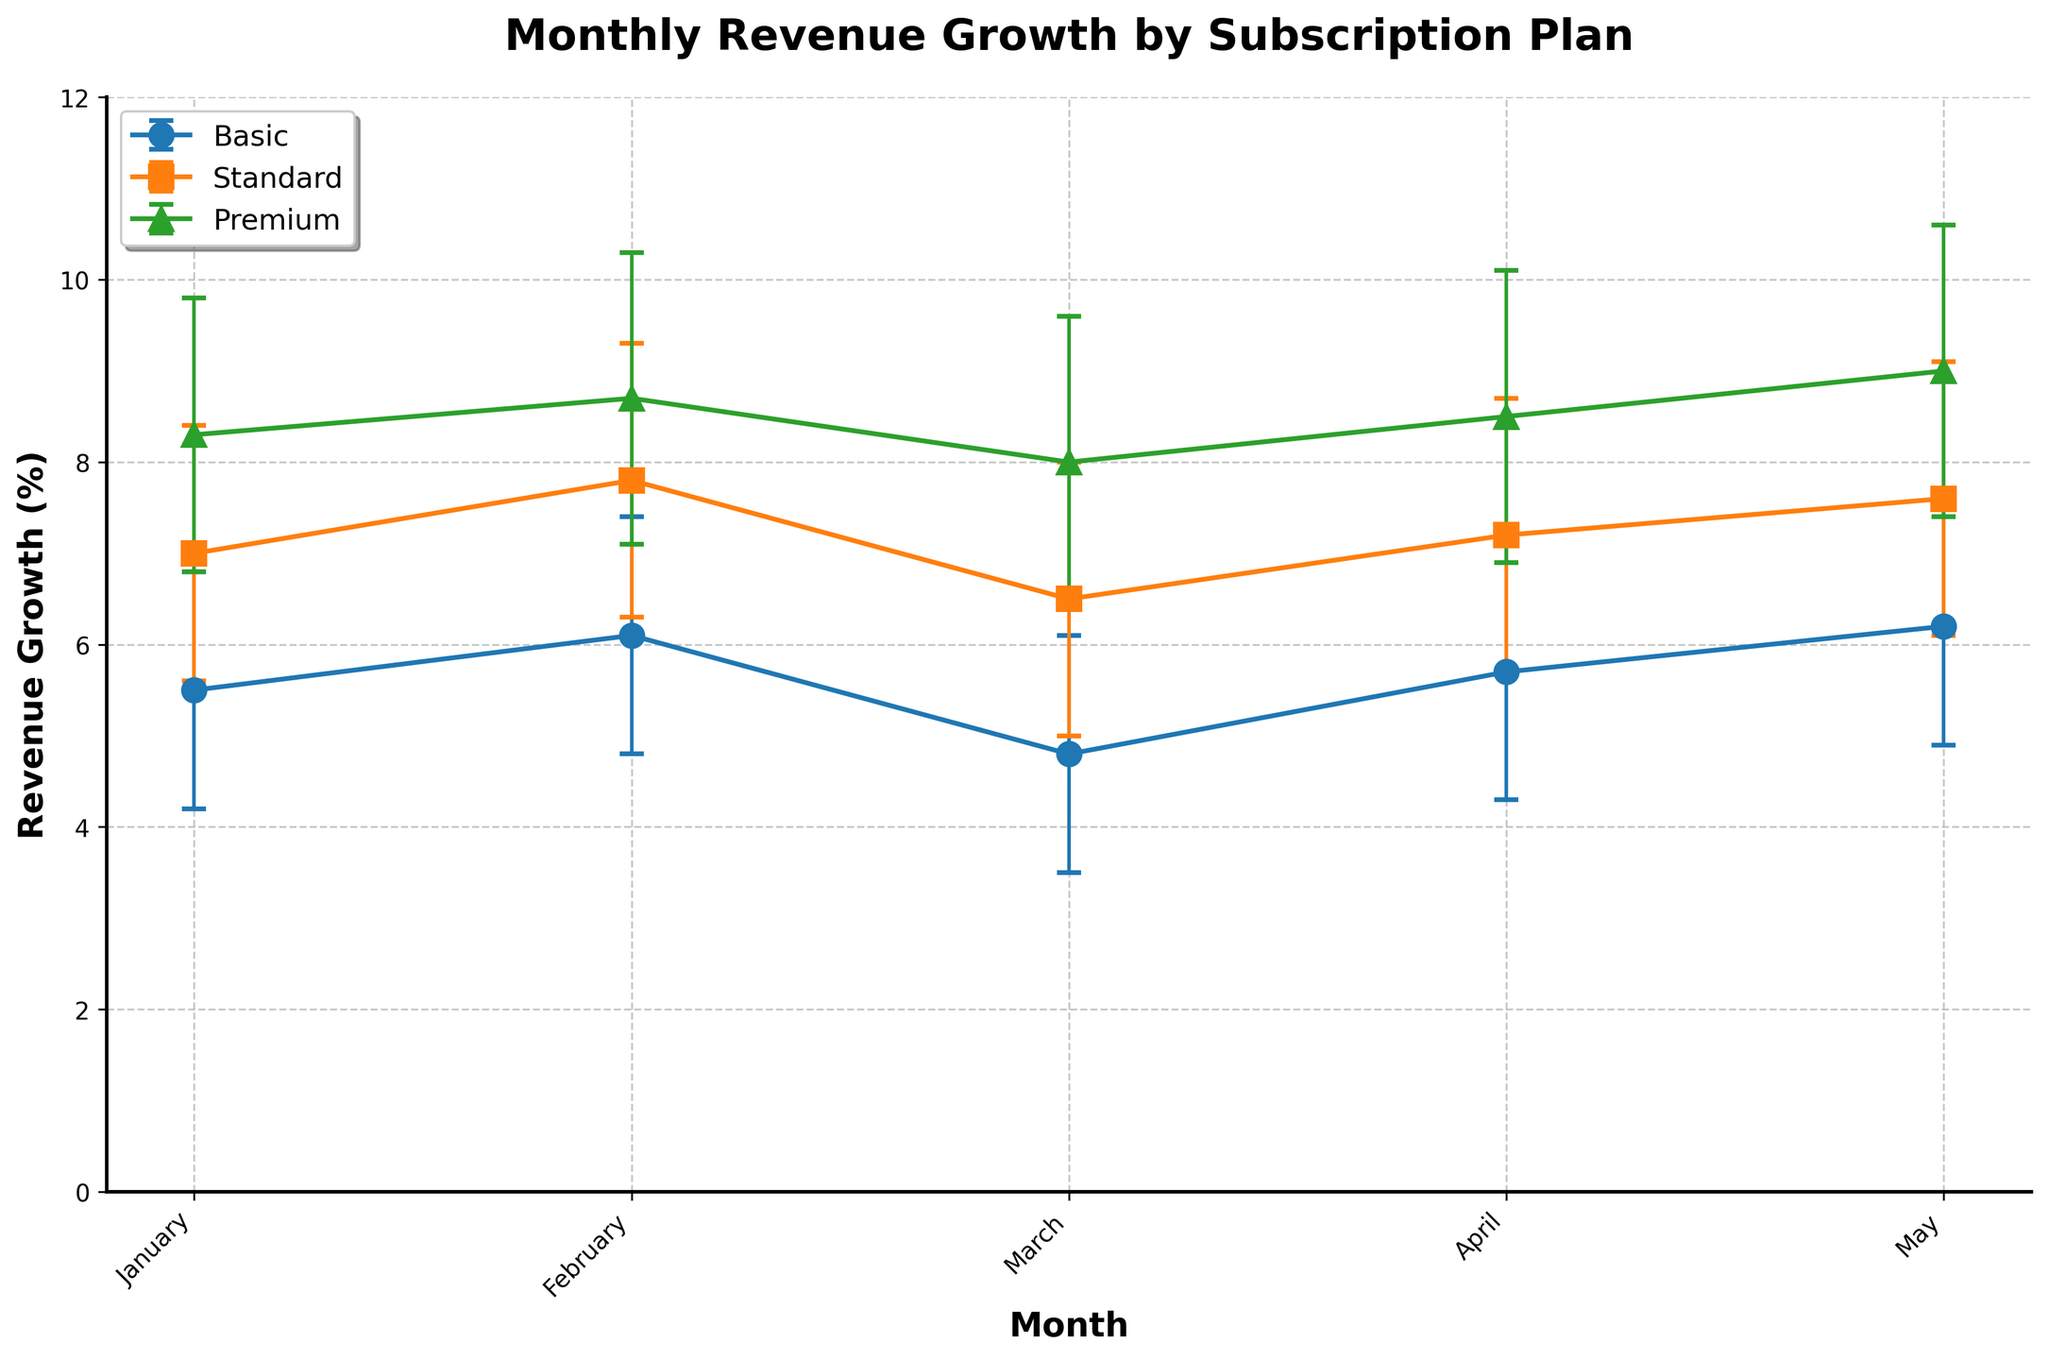What's the title of the figure? The title of the figure is located at the top center and it states the main focus of the visual representation.
Answer: Monthly Revenue Growth by Subscription Plan Which subscription plan shows the highest revenue growth in April? To find this, locate April on the x-axis and compare the revenue growth of all subscription plans. The plan with the highest value will be the highest on the y-axis for that month.
Answer: Premium What does the y-axis represent? The y-axis represents the percentage of revenue growth. This is indicated by the y-axis label which reads "Revenue Growth (%)".
Answer: Revenue Growth (%) How many months' data is displayed in the plot? Count the unique labels on the x-axis which represent the months included in the plot.
Answer: Five In which month is the revenue growth for the Standard plan closest to the Basic plan? Locate the points for the Standard and Basic plans for each month and identify which month they are closest in value by visual inspection.
Answer: March What is the average revenue growth for the Basic plan across all months shown? Sum up the revenue growth values for the Basic plan and divide by the number of months (5). The values are 5.5, 6.1, 4.8, 5.7, and 6.2. (5.5 + 6.1 + 4.8 + 5.7 + 6.2) / 5 = 28.3 / 5
Answer: 5.66 Which subscription plan consistently shows the highest revenue growth throughout all months? Compare the heights of the plotted points of all plans across the months. The plan that is consistently higher than the others on the y-axis is the correct answer.
Answer: Premium Is there any month where the Basic plan surpasses the revenue growth of the Standard plan? Compare the plotted points of Basic and Standard plans for each month. Check if Basic plan's point is higher than Standard plan’s point in any month.
Answer: No How does the growth trend of the Premium plan change over the months? For this, observe the direction and magnitude of changes between successive points of the Premium plan. Assess whether it is an increasing, decreasing or stable trend.
Answer: Increasing What period shows the smallest error margin for the Premium plan? Evaluate the error bars for the Premium plan in each month. Identify the month with the shortest error bars, indicating the smallest error margin.
Answer: February 